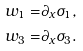<formula> <loc_0><loc_0><loc_500><loc_500>w _ { 1 } = & \partial _ { x } \sigma _ { 1 } , \\ w _ { 3 } = & \partial _ { x } \sigma _ { 3 } .</formula> 